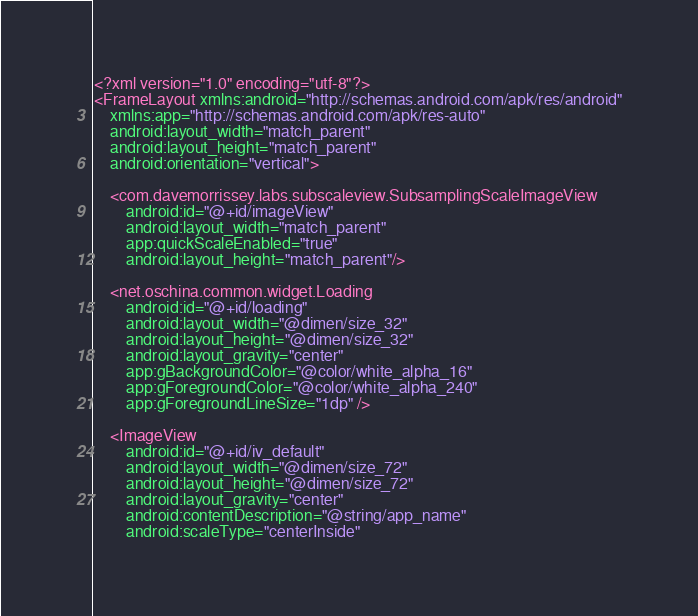<code> <loc_0><loc_0><loc_500><loc_500><_XML_><?xml version="1.0" encoding="utf-8"?>
<FrameLayout xmlns:android="http://schemas.android.com/apk/res/android"
    xmlns:app="http://schemas.android.com/apk/res-auto"
    android:layout_width="match_parent"
    android:layout_height="match_parent"
    android:orientation="vertical">

    <com.davemorrissey.labs.subscaleview.SubsamplingScaleImageView
        android:id="@+id/imageView"
        android:layout_width="match_parent"
        app:quickScaleEnabled="true"
        android:layout_height="match_parent"/>

    <net.oschina.common.widget.Loading
        android:id="@+id/loading"
        android:layout_width="@dimen/size_32"
        android:layout_height="@dimen/size_32"
        android:layout_gravity="center"
        app:gBackgroundColor="@color/white_alpha_16"
        app:gForegroundColor="@color/white_alpha_240"
        app:gForegroundLineSize="1dp" />

    <ImageView
        android:id="@+id/iv_default"
        android:layout_width="@dimen/size_72"
        android:layout_height="@dimen/size_72"
        android:layout_gravity="center"
        android:contentDescription="@string/app_name"
        android:scaleType="centerInside"</code> 